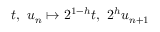Convert formula to latex. <formula><loc_0><loc_0><loc_500><loc_500>t , \ u _ { n } \mapsto 2 ^ { 1 - h } t , \ 2 ^ { h } u _ { n + 1 }</formula> 